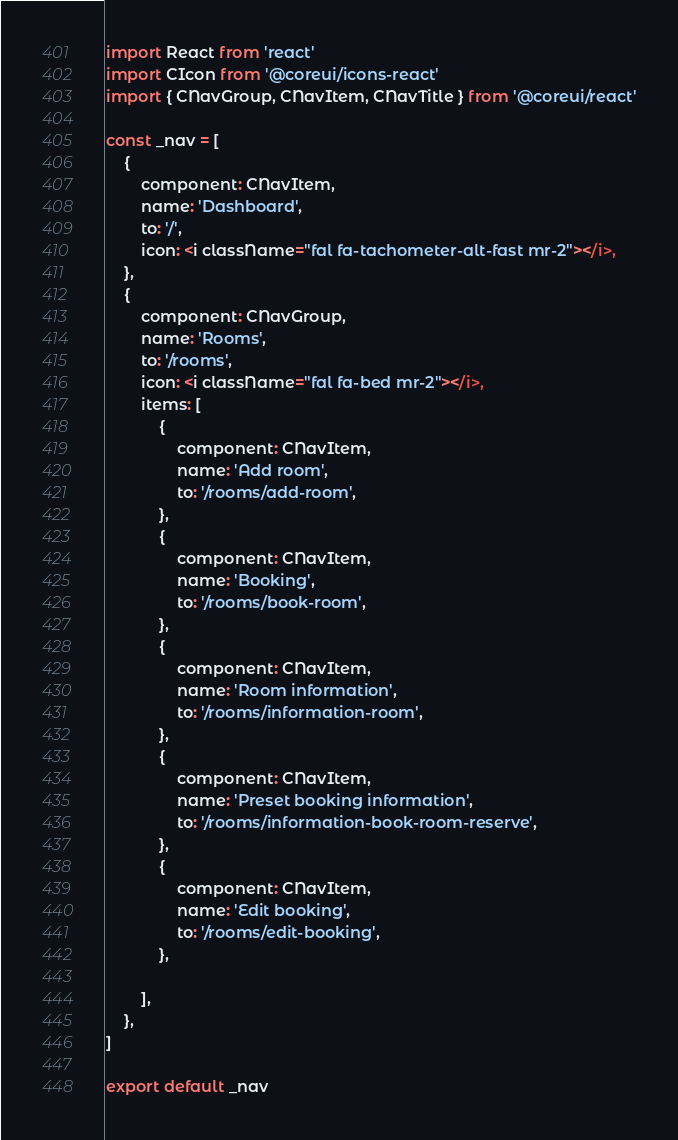Convert code to text. <code><loc_0><loc_0><loc_500><loc_500><_JavaScript_>import React from 'react'
import CIcon from '@coreui/icons-react'
import { CNavGroup, CNavItem, CNavTitle } from '@coreui/react'

const _nav = [
    {
        component: CNavItem,
        name: 'Dashboard',
        to: '/',
        icon: <i className="fal fa-tachometer-alt-fast mr-2"></i>,
    },
    {
        component: CNavGroup,
        name: 'Rooms',
        to: '/rooms',
        icon: <i className="fal fa-bed mr-2"></i>,
        items: [
            {
                component: CNavItem,
                name: 'Add room',
                to: '/rooms/add-room',
            },
            {
                component: CNavItem,
                name: 'Booking',
                to: '/rooms/book-room',
            },
            {
                component: CNavItem,
                name: 'Room information',
                to: '/rooms/information-room',
            },
            {
                component: CNavItem,
                name: 'Preset booking information',
                to: '/rooms/information-book-room-reserve',
            },
            {
                component: CNavItem,
                name: 'Edit booking',
                to: '/rooms/edit-booking',
            },

        ],
    },
]

export default _nav
</code> 